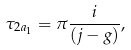<formula> <loc_0><loc_0><loc_500><loc_500>\tau _ { 2 a _ { 1 } } = \pi \frac { i } { ( j - g ) } ,</formula> 